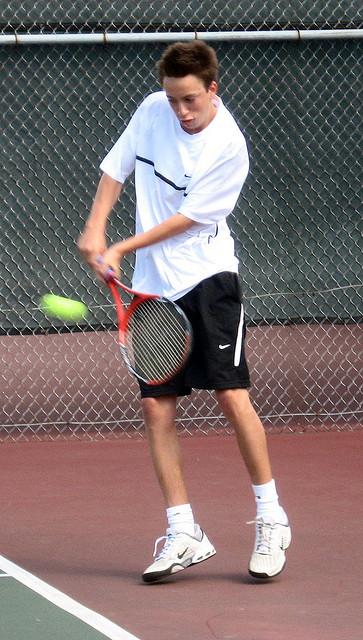What is the swinging at the ball?
Be succinct. Racket. What color is the court?
Concise answer only. Red. Is this person playing golf?
Answer briefly. No. What color is his shorts?
Give a very brief answer. Black. 